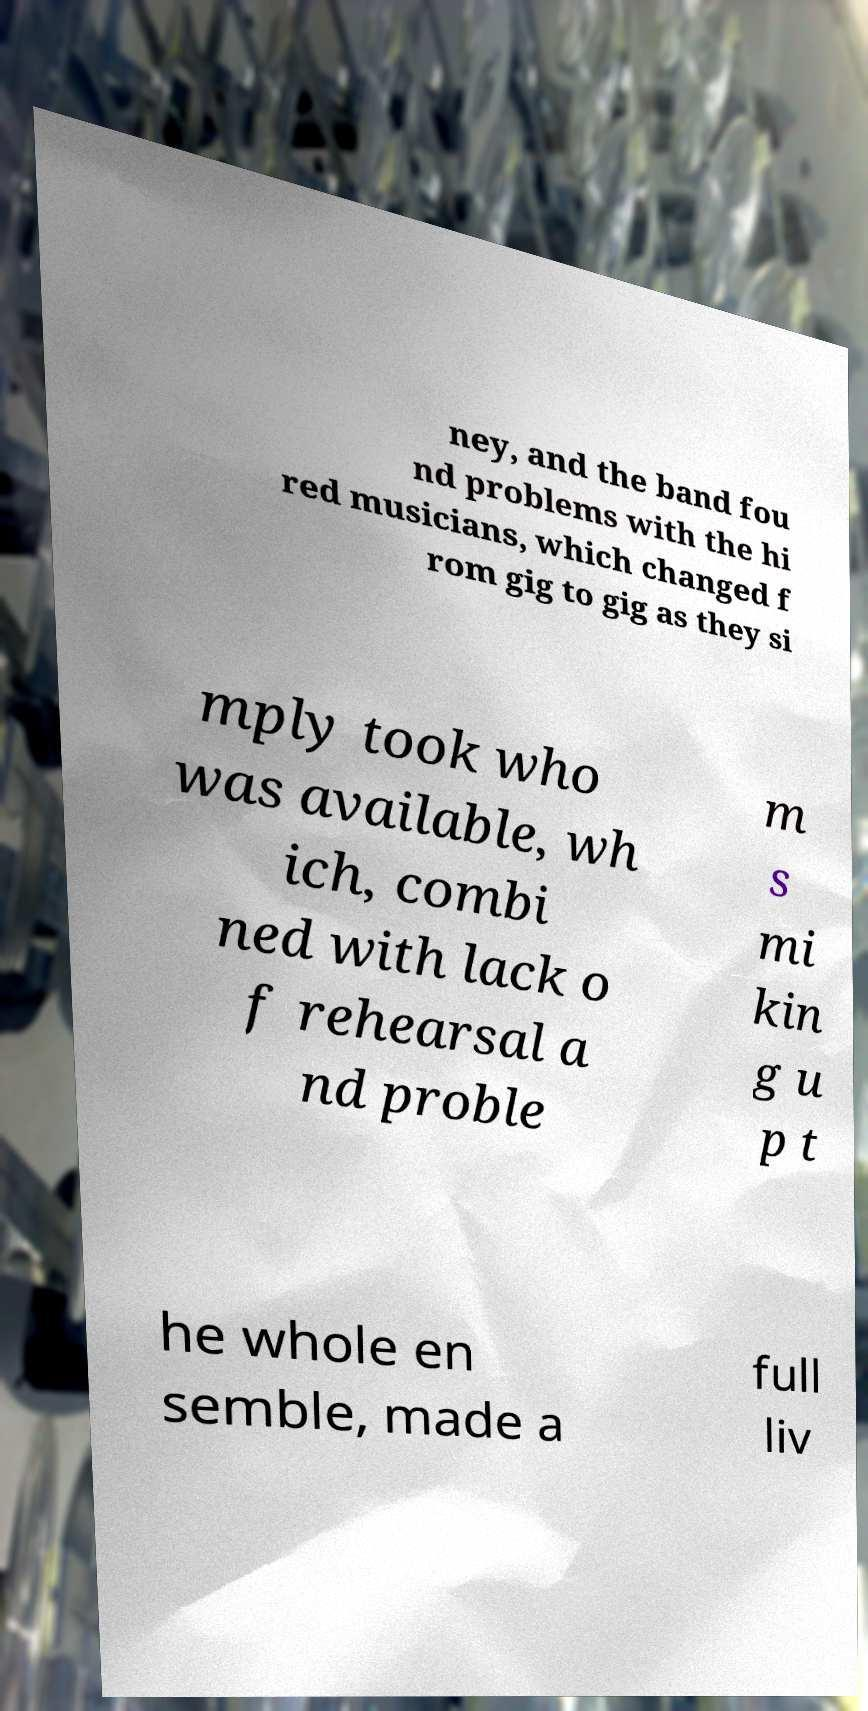Could you assist in decoding the text presented in this image and type it out clearly? ney, and the band fou nd problems with the hi red musicians, which changed f rom gig to gig as they si mply took who was available, wh ich, combi ned with lack o f rehearsal a nd proble m s mi kin g u p t he whole en semble, made a full liv 